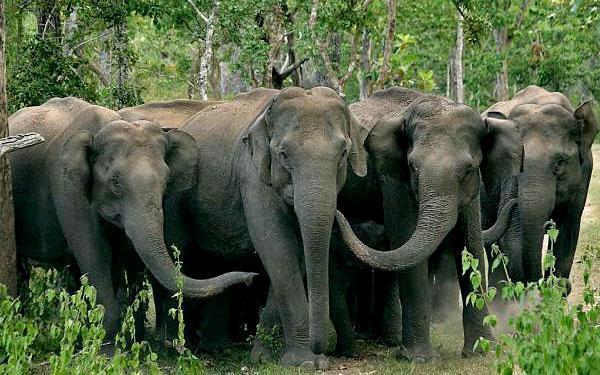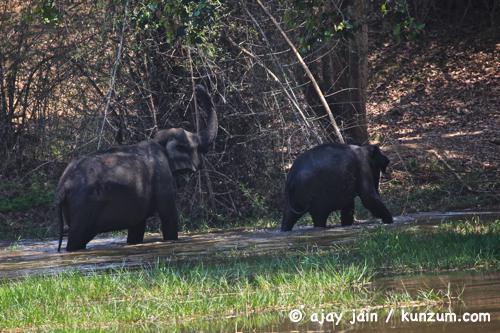The first image is the image on the left, the second image is the image on the right. Analyze the images presented: Is the assertion "The right image contains only one elephant." valid? Answer yes or no. No. The first image is the image on the left, the second image is the image on the right. Given the left and right images, does the statement "The right image contains a single elephant with large tusks." hold true? Answer yes or no. No. 